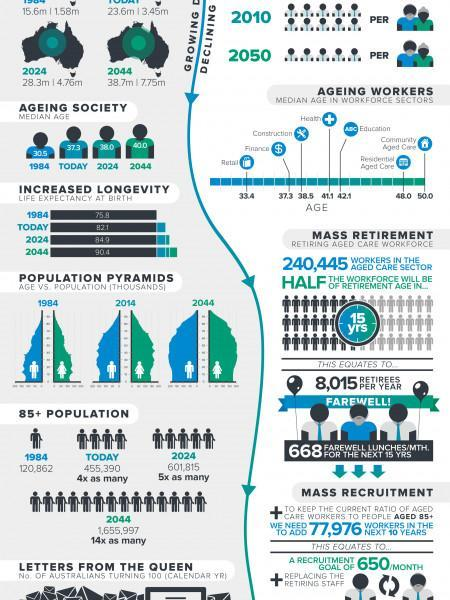What will be the population of older people by 2024?
Answer the question with a short phrase. 601,815 What is the halfway age of the people in the current year? 37.3 In which year life expectancy rate will be the second-highest? 2024 What is the median age of health workers? 41.1 What is the median age of Construction workers? 38.5 What is the median age of Education workers? 42.1 In which work sector highest median aged people works? Community Aged Care What is the population of older people in the current year? 455,390 What is the life expectancy rate of the current year? 82.1 What will be the halfway age of the people by 2024? 38.0 